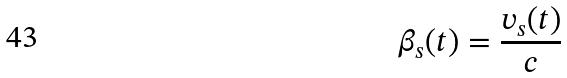Convert formula to latex. <formula><loc_0><loc_0><loc_500><loc_500>\beta _ { s } ( t ) = \frac { v _ { s } ( t ) } { c }</formula> 